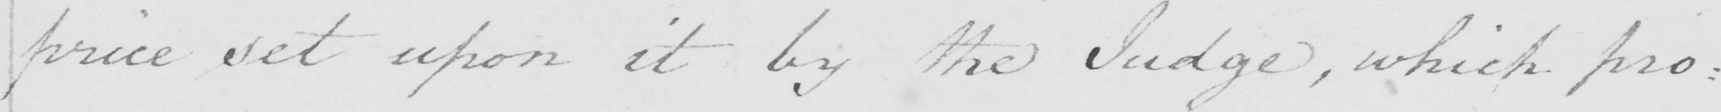Please provide the text content of this handwritten line. price set upon it by the Judge , which pro= 